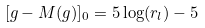<formula> <loc_0><loc_0><loc_500><loc_500>[ g - M ( g ) ] _ { 0 } = 5 \log ( r _ { l } ) - 5 \\</formula> 